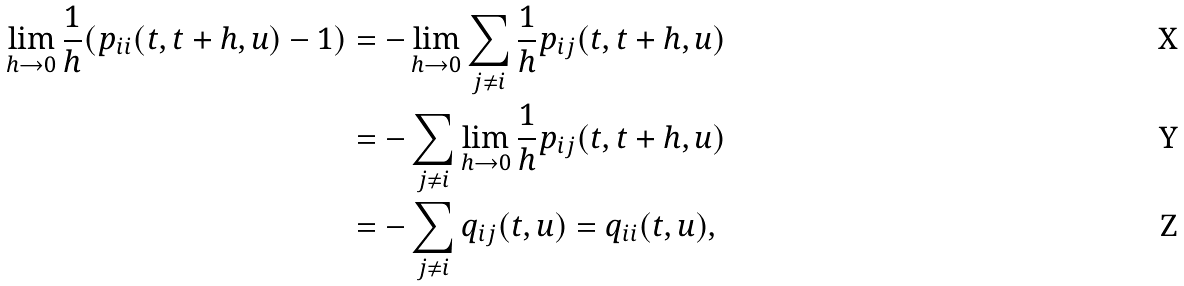<formula> <loc_0><loc_0><loc_500><loc_500>\lim _ { h \to 0 } \frac { 1 } { h } ( p _ { i i } ( t , t + h , u ) - 1 ) & = - \lim _ { h \to 0 } \sum _ { j \neq i } \frac { 1 } { h } p _ { i j } ( t , t + h , u ) \\ & = - \sum _ { j \neq i } \lim _ { h \to 0 } \frac { 1 } { h } p _ { i j } ( t , t + h , u ) \\ & = - \sum _ { j \neq i } q _ { i j } ( t , u ) = q _ { i i } ( t , u ) ,</formula> 